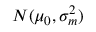<formula> <loc_0><loc_0><loc_500><loc_500>N ( \mu _ { 0 } , \sigma _ { m } ^ { 2 } )</formula> 